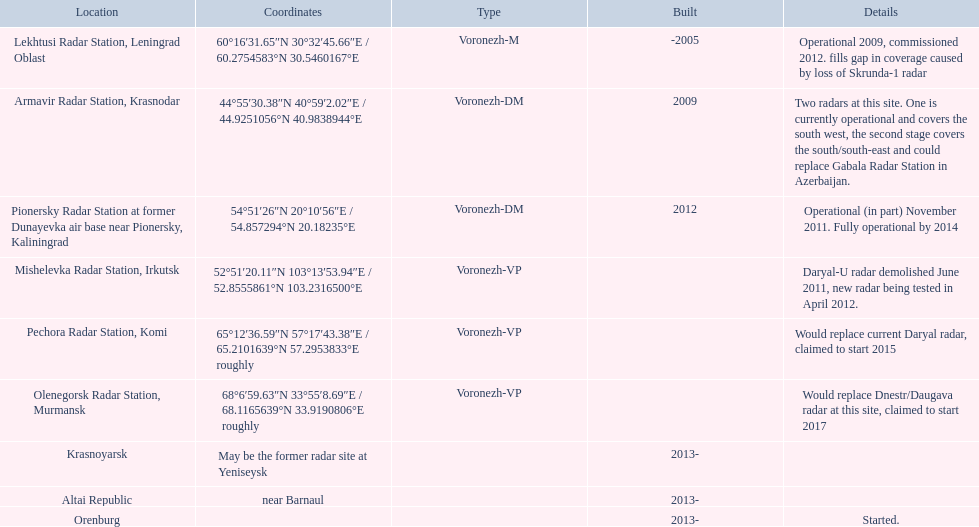Which voronezh radar has already started? Orenburg. Which radar would replace dnestr/daugava? Olenegorsk Radar Station, Murmansk. Which radar started in 2015? Pechora Radar Station, Komi. 